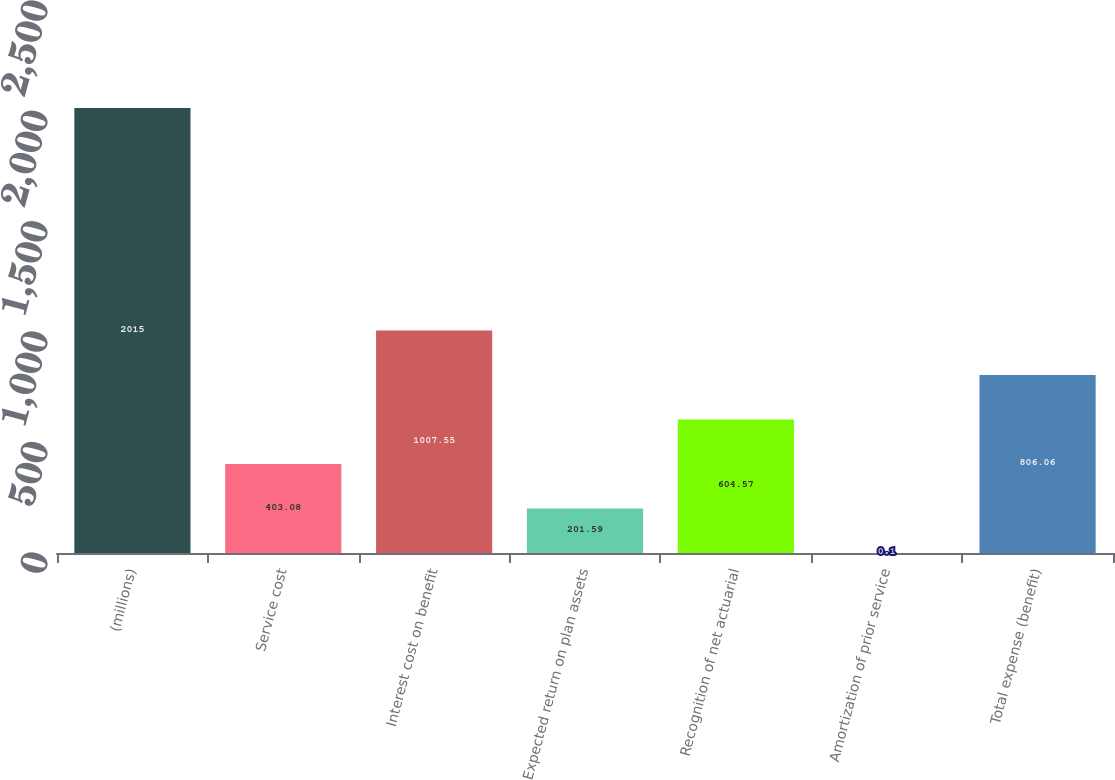Convert chart. <chart><loc_0><loc_0><loc_500><loc_500><bar_chart><fcel>(millions)<fcel>Service cost<fcel>Interest cost on benefit<fcel>Expected return on plan assets<fcel>Recognition of net actuarial<fcel>Amortization of prior service<fcel>Total expense (benefit)<nl><fcel>2015<fcel>403.08<fcel>1007.55<fcel>201.59<fcel>604.57<fcel>0.1<fcel>806.06<nl></chart> 